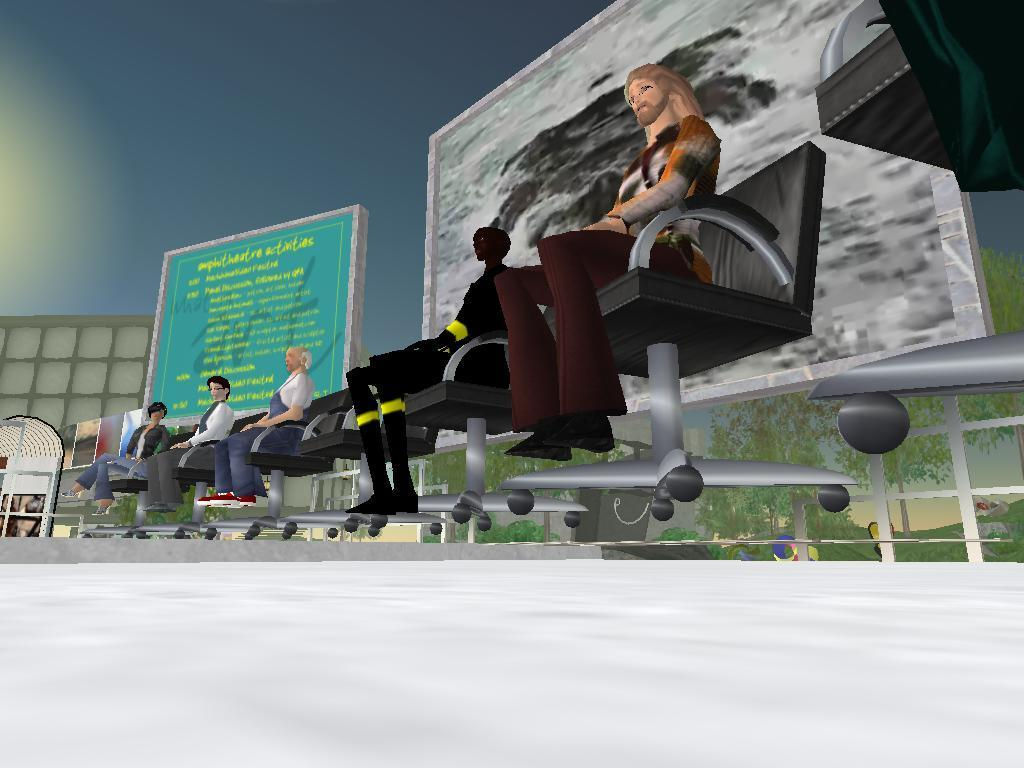What type of picture is the image? The image is an animated picture. What are the people in the image doing? The people are sitting on chairs. What can be seen in the background of the image? There are screens and trees in the background, and the sky is visible. What type of oil is being used to cook the chicken in the image? There is no oil or chicken present in the image; it features an animated scene with people sitting on chairs and a background with screens, trees, and the sky. 